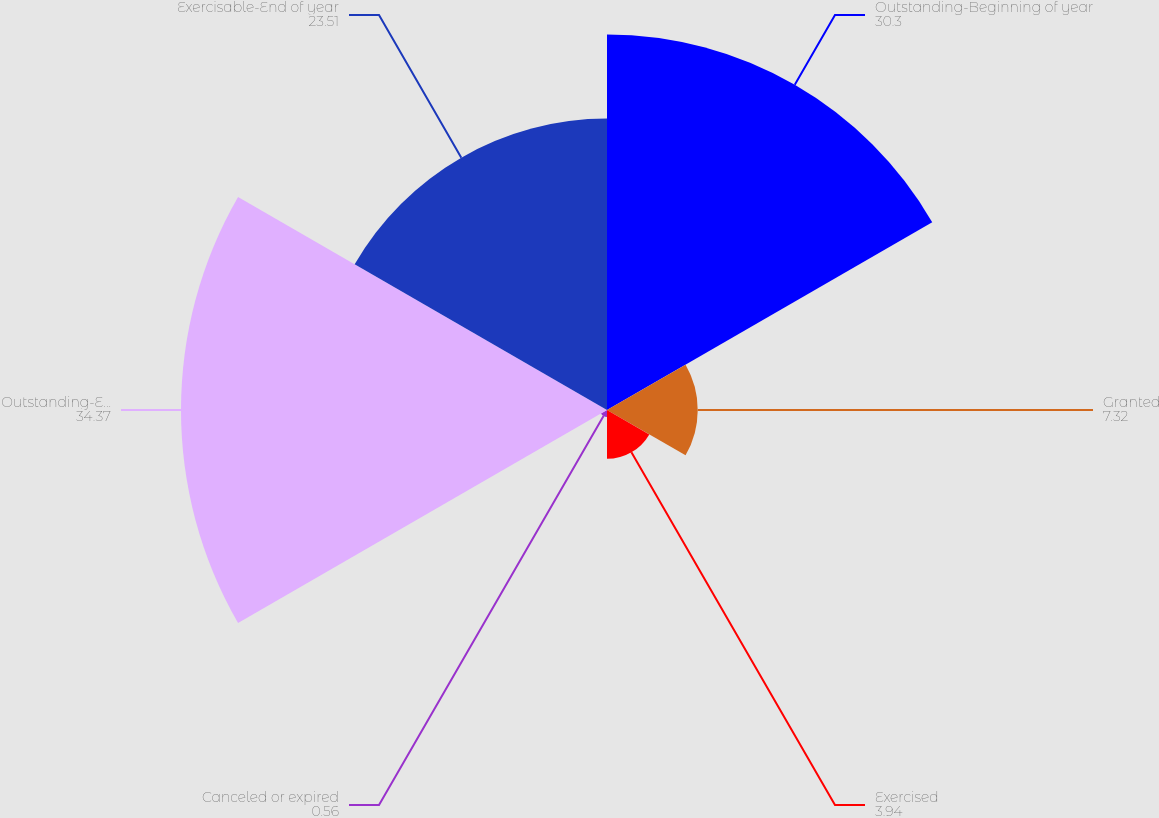Convert chart to OTSL. <chart><loc_0><loc_0><loc_500><loc_500><pie_chart><fcel>Outstanding-Beginning of year<fcel>Granted<fcel>Exercised<fcel>Canceled or expired<fcel>Outstanding-End of year(a)<fcel>Exercisable-End of year<nl><fcel>30.3%<fcel>7.32%<fcel>3.94%<fcel>0.56%<fcel>34.37%<fcel>23.51%<nl></chart> 